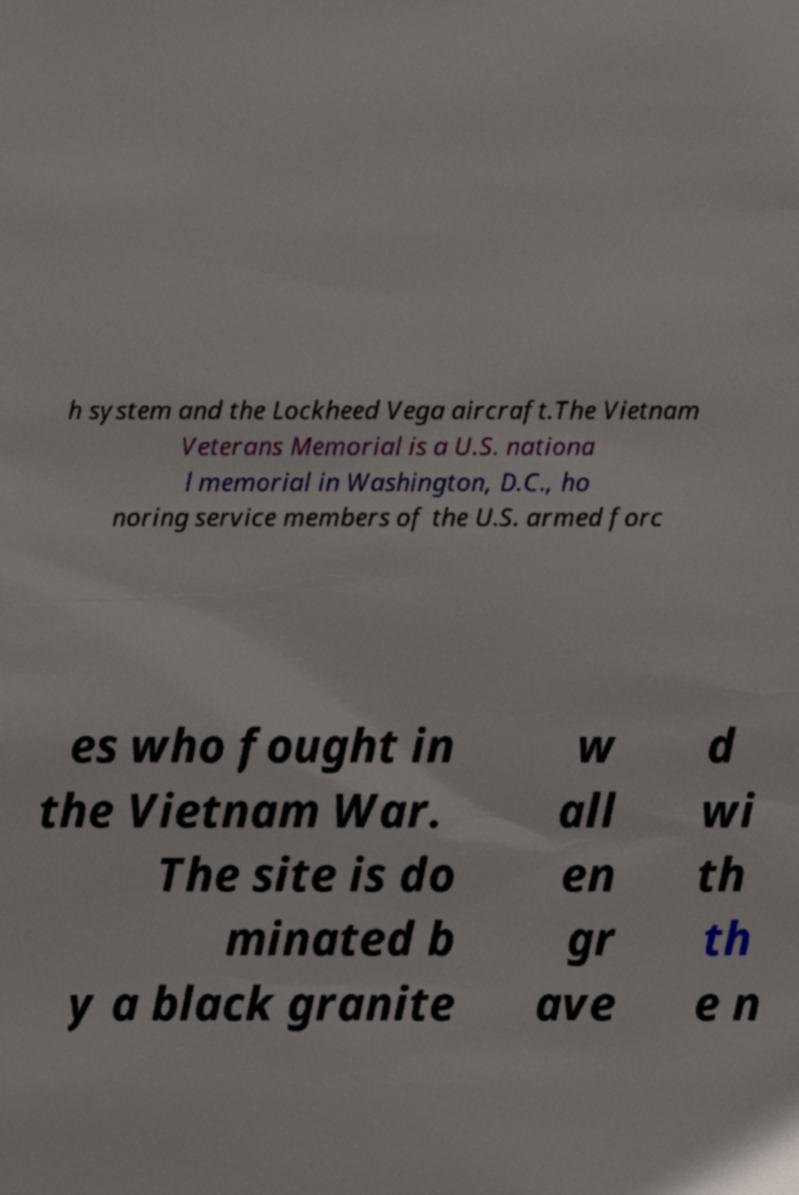Please read and relay the text visible in this image. What does it say? h system and the Lockheed Vega aircraft.The Vietnam Veterans Memorial is a U.S. nationa l memorial in Washington, D.C., ho noring service members of the U.S. armed forc es who fought in the Vietnam War. The site is do minated b y a black granite w all en gr ave d wi th th e n 